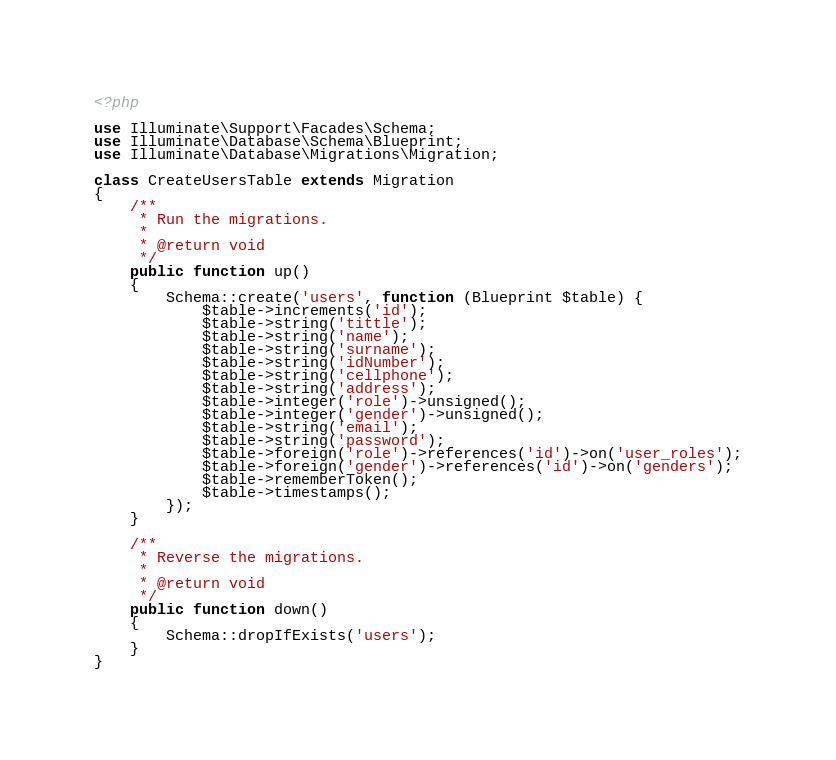<code> <loc_0><loc_0><loc_500><loc_500><_PHP_><?php

use Illuminate\Support\Facades\Schema;
use Illuminate\Database\Schema\Blueprint;
use Illuminate\Database\Migrations\Migration;

class CreateUsersTable extends Migration
{
    /**
     * Run the migrations.
     *
     * @return void
     */
    public function up()
    {
        Schema::create('users', function (Blueprint $table) {
            $table->increments('id');
            $table->string('tittle');
            $table->string('name');
            $table->string('surname');
            $table->string('idNumber');
            $table->string('cellphone');
            $table->string('address');
            $table->integer('role')->unsigned();
            $table->integer('gender')->unsigned();
            $table->string('email');
            $table->string('password');
            $table->foreign('role')->references('id')->on('user_roles');
            $table->foreign('gender')->references('id')->on('genders');
            $table->rememberToken();
            $table->timestamps();
        });
    }

    /**
     * Reverse the migrations.
     *
     * @return void
     */
    public function down()
    {
        Schema::dropIfExists('users');
    }
}
</code> 